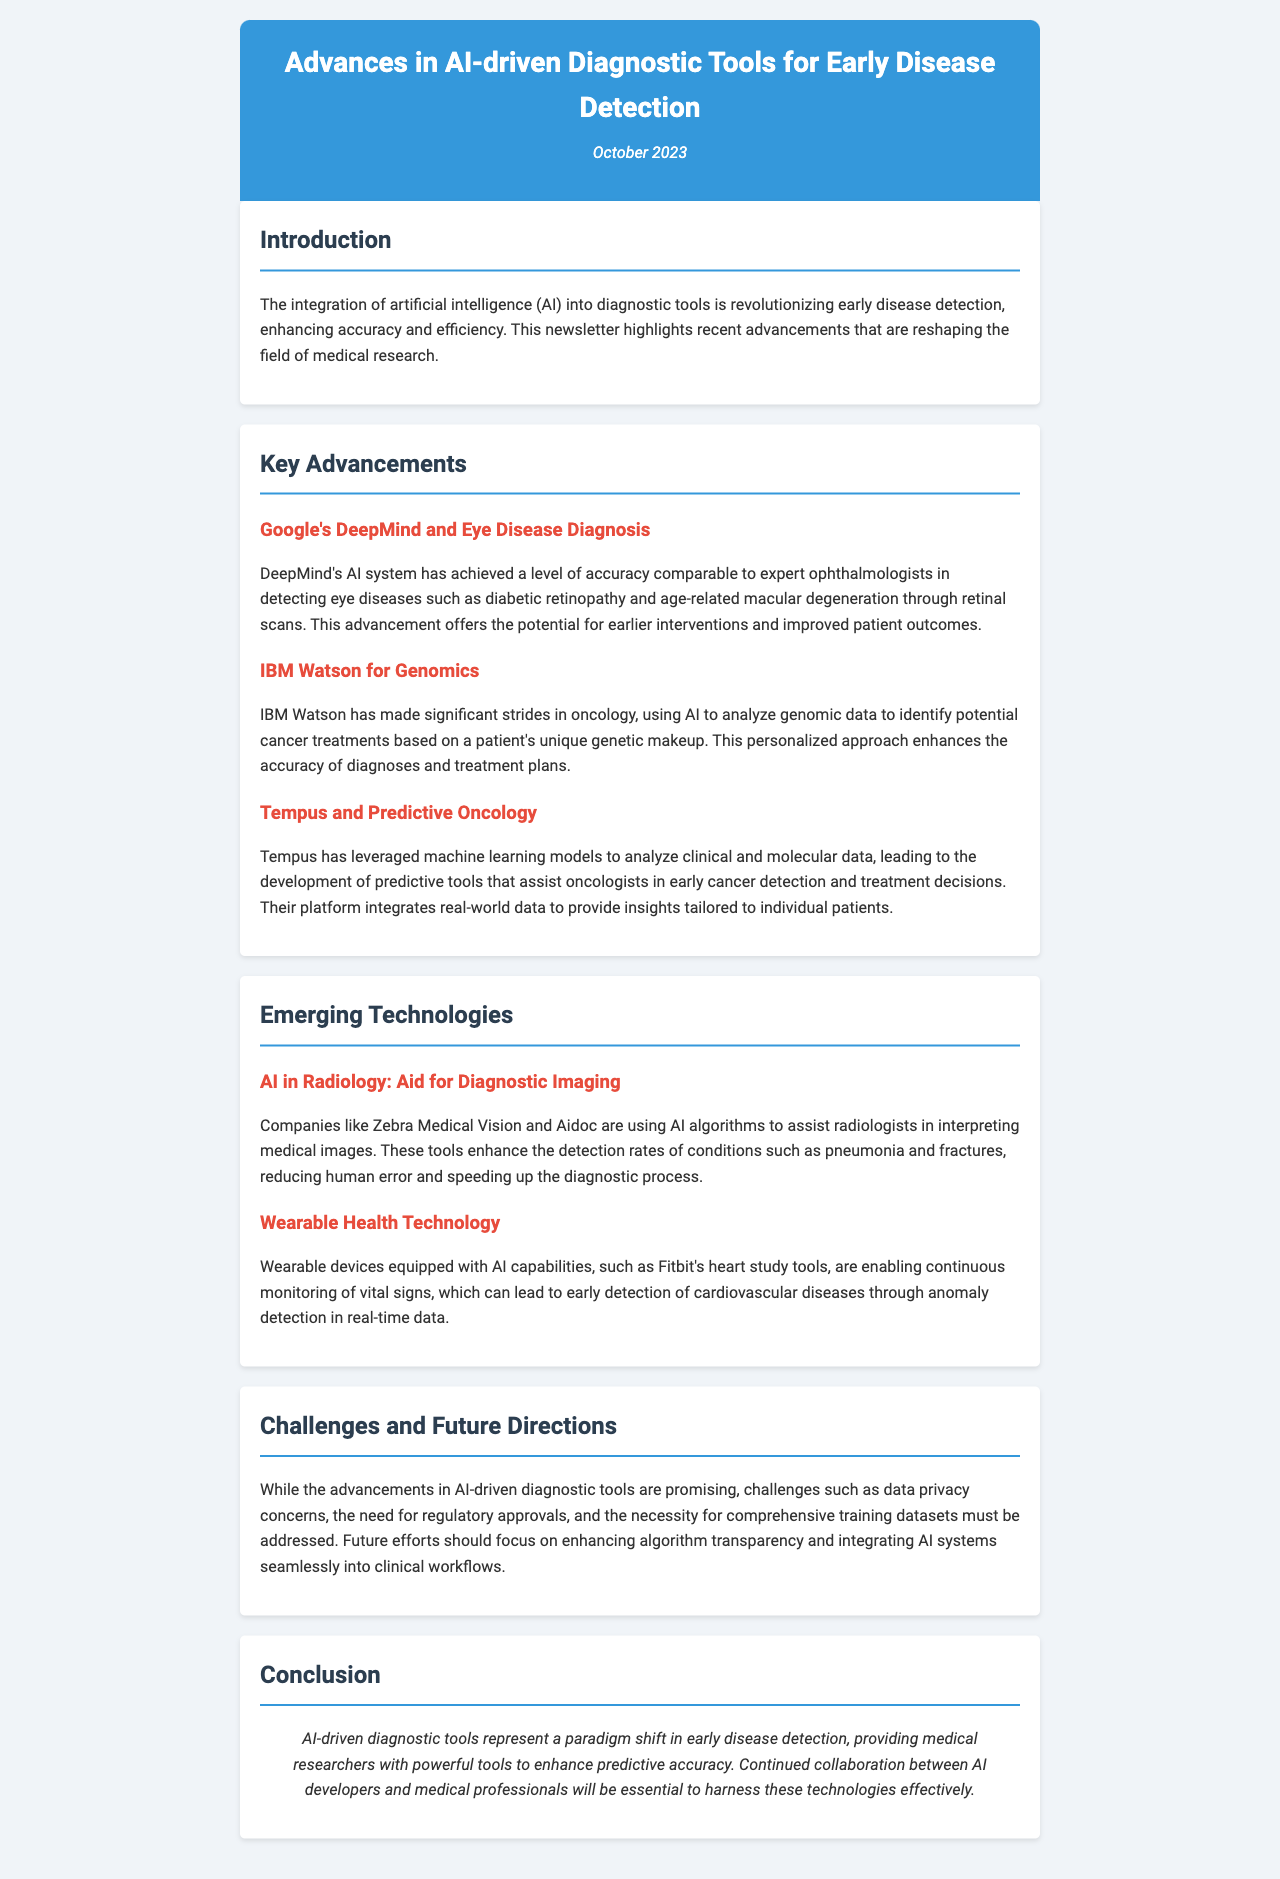What is the title of the newsletter? The title of the newsletter is found in the header section.
Answer: Advances in AI-driven Diagnostic Tools for Early Disease Detection Which organization's AI system is noted for eye disease diagnosis? The organization noted for eye disease diagnosis is mentioned in the key advancements section.
Answer: Google's DeepMind What percentage of diagnostic accuracy does DeepMind achieve? The accuracy level is described in comparison to expert ophthalmologists but not as a percentage; instead, it’s qualitative information.
Answer: Comparable What technology does IBM Watson focus on? The technology focus of IBM Watson is detailed in the key advancements section.
Answer: Genomics What is a key challenge mentioned for AI-driven diagnostic tools? The section discusses multiple challenges for AI-driven tools, which are mentioned explicitly.
Answer: Data privacy concerns Which wearable technology is mentioned in the newsletter? The specific example of wearable technology is presented in the emerging technologies section.
Answer: Fitbit's heart study tools How are AI algorithms used in radiology according to the document? The document outlines the role of AI algorithms in assisting with medical image interpretation.
Answer: To assist radiologists What is one of the future directions for AI-driven diagnostic tools? The future directions are summarized in the challenges and future directions section.
Answer: Enhancing algorithm transparency 